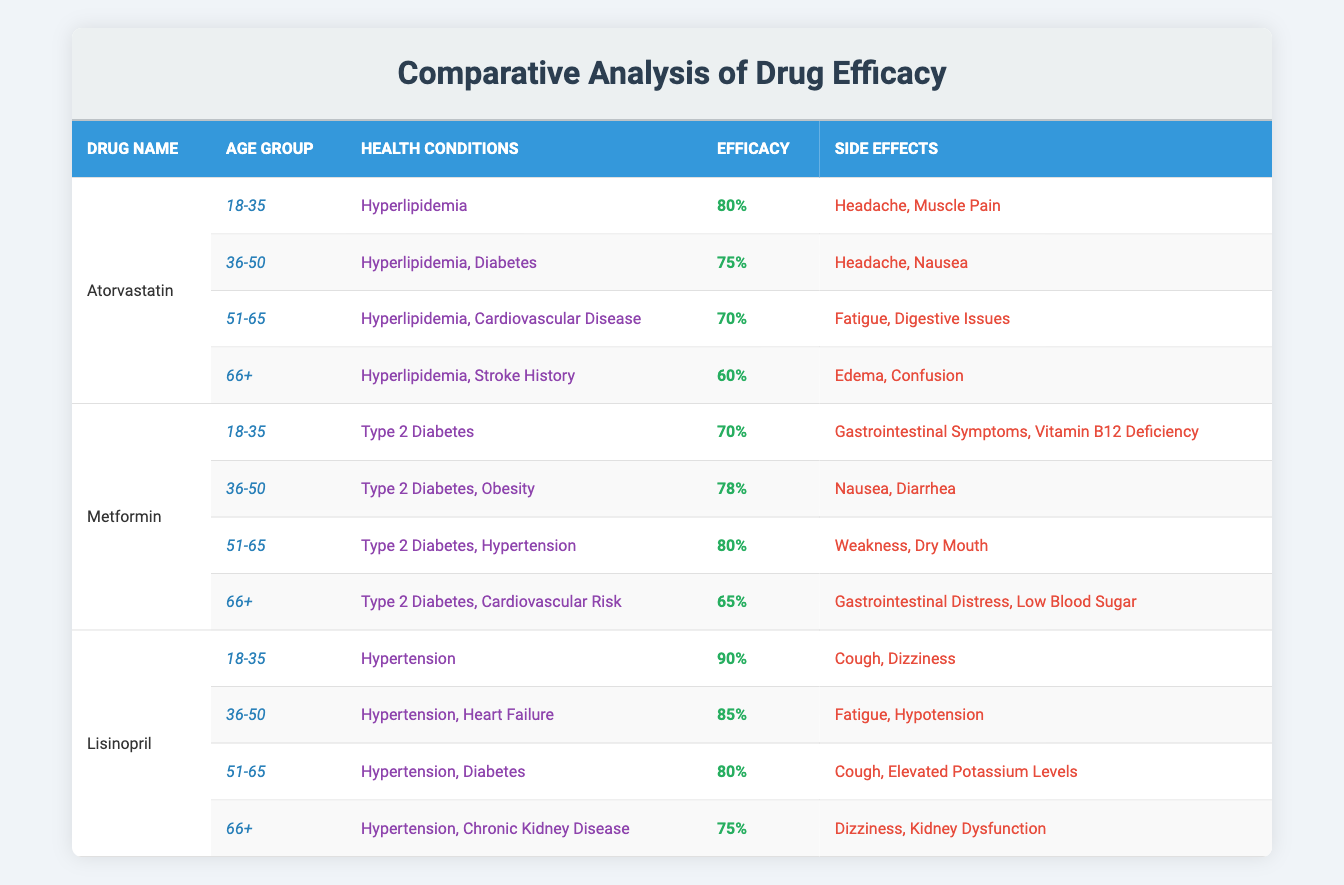What is the efficacy percentage of Lisinopril in the 18-35 age group? Lisinopril for the 18-35 age group has an efficacy of 90%, as stated directly in the table.
Answer: 90% Which drug has the highest efficacy percentage for patients aged 36-50? Atorvastatin has an efficacy of 75% for the 36-50 age group, while Lisinopril has 85%. Therefore, Lisinopril has the highest efficacy percentage.
Answer: Lisinopril What are the side effects of Metformin for patients aged 51-65? The table indicates that for patients aged 51-65, Metformin's side effects include weakness and dry mouth.
Answer: Weakness, Dry Mouth Is the efficacy of Atorvastatin lower for patients aged 66 and older compared to those aged 18-35? Atorvastatin's efficacy for the 66+ age group is 60%, while for the 18-35 age group, it is 80%. Since 60% is lower than 80%, the statement is true.
Answer: Yes What is the average efficacy percentage of Lisinopril across all age groups? The efficacy percentages of Lisinopril across all age groups are 90%, 85%, 80%, and 75%. Adding these gives a total of 330%. Dividing by 4 age groups results in an average of 82.5%.
Answer: 82.5% Which age group for Metformin shows the highest efficacy percentage? Reviewing the efficacy percentages for Metformin: 70% (18-35), 78% (36-50), 80% (51-65), and 65% (66+), the 51-65 age group shows the highest efficacy percentage at 80%.
Answer: 51-65 Are there any age groups for Atorvastatin where the efficacy drops below 70%? The efficacy percentages for Atorvastatin are 80% (18-35), 75% (36-50), 70% (51-65), and 60% (66+). The percentage drops below 70% only for the 66+ age group, which is true.
Answer: Yes How does the efficacy of Metformin for patients aged 66 and older compare to that of Lisinopril in the same age group? Metformin is 65% effective for patients aged 66+, while Lisinopril shows 75% efficacy for the same age bracket. Since 75% is greater than 65%, Lisinopril is more effective.
Answer: Lisinopril is more effective 